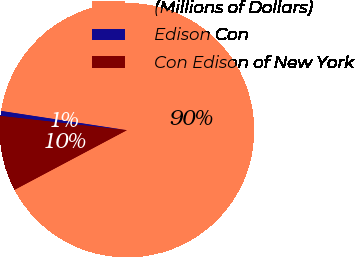Convert chart. <chart><loc_0><loc_0><loc_500><loc_500><pie_chart><fcel>(Millions of Dollars)<fcel>Edison Con<fcel>Con Edison of New York<nl><fcel>89.83%<fcel>0.63%<fcel>9.55%<nl></chart> 